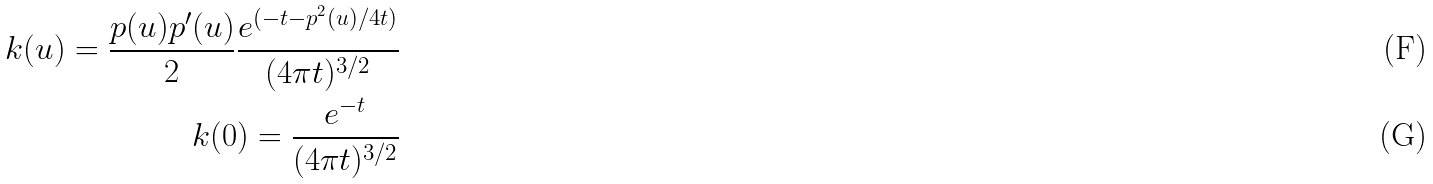Convert formula to latex. <formula><loc_0><loc_0><loc_500><loc_500>k ( u ) = \frac { p ( u ) p ^ { \prime } ( u ) } { 2 } \frac { e ^ { ( - t - p ^ { 2 } ( u ) / 4 t ) } } { ( 4 \pi t ) ^ { 3 / 2 } } \\ k ( 0 ) = \frac { e ^ { - t } } { ( 4 \pi t ) ^ { 3 / 2 } }</formula> 